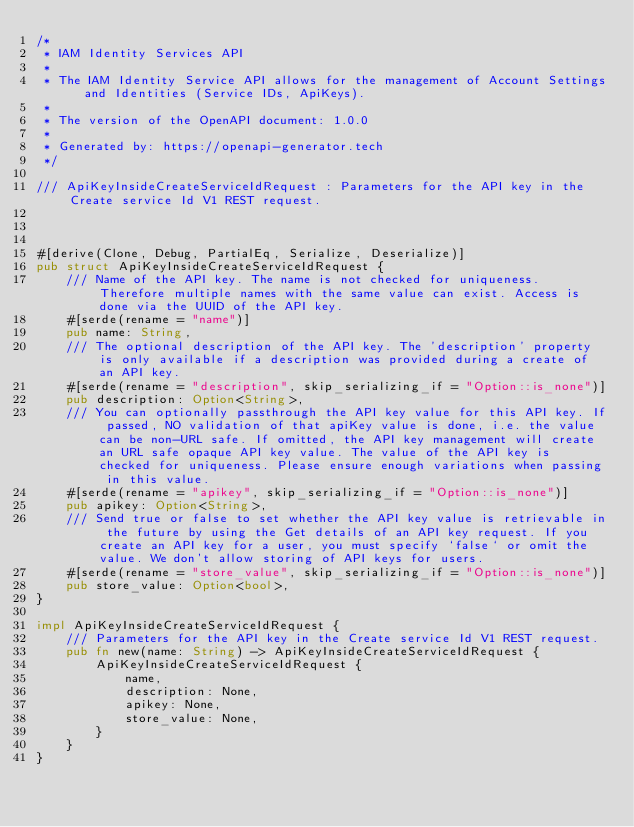<code> <loc_0><loc_0><loc_500><loc_500><_Rust_>/*
 * IAM Identity Services API
 *
 * The IAM Identity Service API allows for the management of Account Settings and Identities (Service IDs, ApiKeys).
 *
 * The version of the OpenAPI document: 1.0.0
 * 
 * Generated by: https://openapi-generator.tech
 */

/// ApiKeyInsideCreateServiceIdRequest : Parameters for the API key in the Create service Id V1 REST request.



#[derive(Clone, Debug, PartialEq, Serialize, Deserialize)]
pub struct ApiKeyInsideCreateServiceIdRequest {
    /// Name of the API key. The name is not checked for uniqueness. Therefore multiple names with the same value can exist. Access is done via the UUID of the API key.
    #[serde(rename = "name")]
    pub name: String,
    /// The optional description of the API key. The 'description' property is only available if a description was provided during a create of an API key.
    #[serde(rename = "description", skip_serializing_if = "Option::is_none")]
    pub description: Option<String>,
    /// You can optionally passthrough the API key value for this API key. If passed, NO validation of that apiKey value is done, i.e. the value can be non-URL safe. If omitted, the API key management will create an URL safe opaque API key value. The value of the API key is checked for uniqueness. Please ensure enough variations when passing in this value.
    #[serde(rename = "apikey", skip_serializing_if = "Option::is_none")]
    pub apikey: Option<String>,
    /// Send true or false to set whether the API key value is retrievable in the future by using the Get details of an API key request. If you create an API key for a user, you must specify `false` or omit the value. We don't allow storing of API keys for users.
    #[serde(rename = "store_value", skip_serializing_if = "Option::is_none")]
    pub store_value: Option<bool>,
}

impl ApiKeyInsideCreateServiceIdRequest {
    /// Parameters for the API key in the Create service Id V1 REST request.
    pub fn new(name: String) -> ApiKeyInsideCreateServiceIdRequest {
        ApiKeyInsideCreateServiceIdRequest {
            name,
            description: None,
            apikey: None,
            store_value: None,
        }
    }
}


</code> 